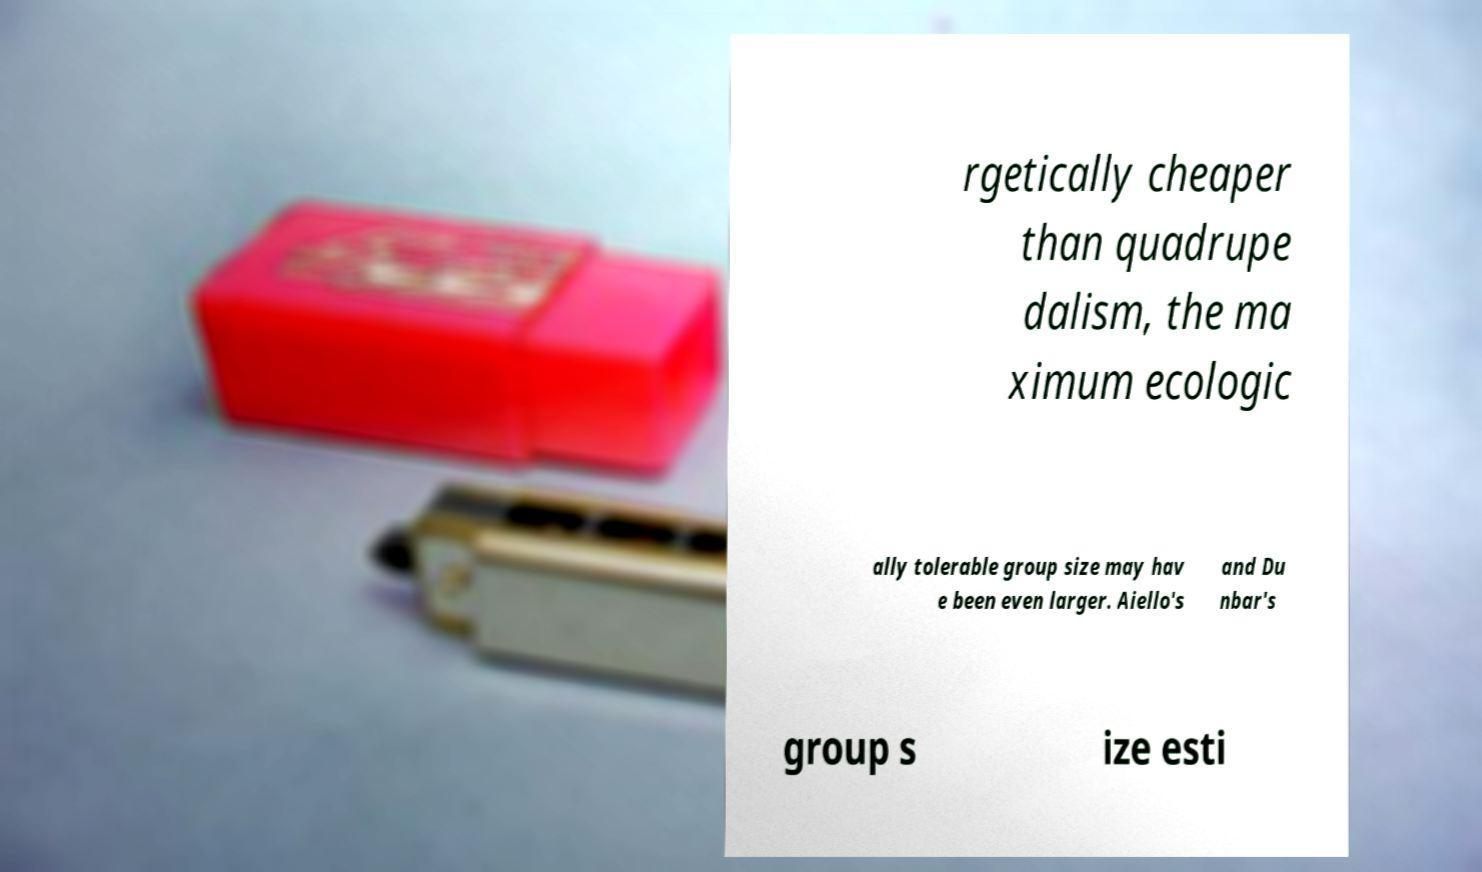There's text embedded in this image that I need extracted. Can you transcribe it verbatim? rgetically cheaper than quadrupe dalism, the ma ximum ecologic ally tolerable group size may hav e been even larger. Aiello's and Du nbar's group s ize esti 